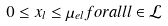Convert formula to latex. <formula><loc_0><loc_0><loc_500><loc_500>0 \leq x _ { l } \leq \mu _ { e l } f o r a l l l \in \mathcal { L }</formula> 